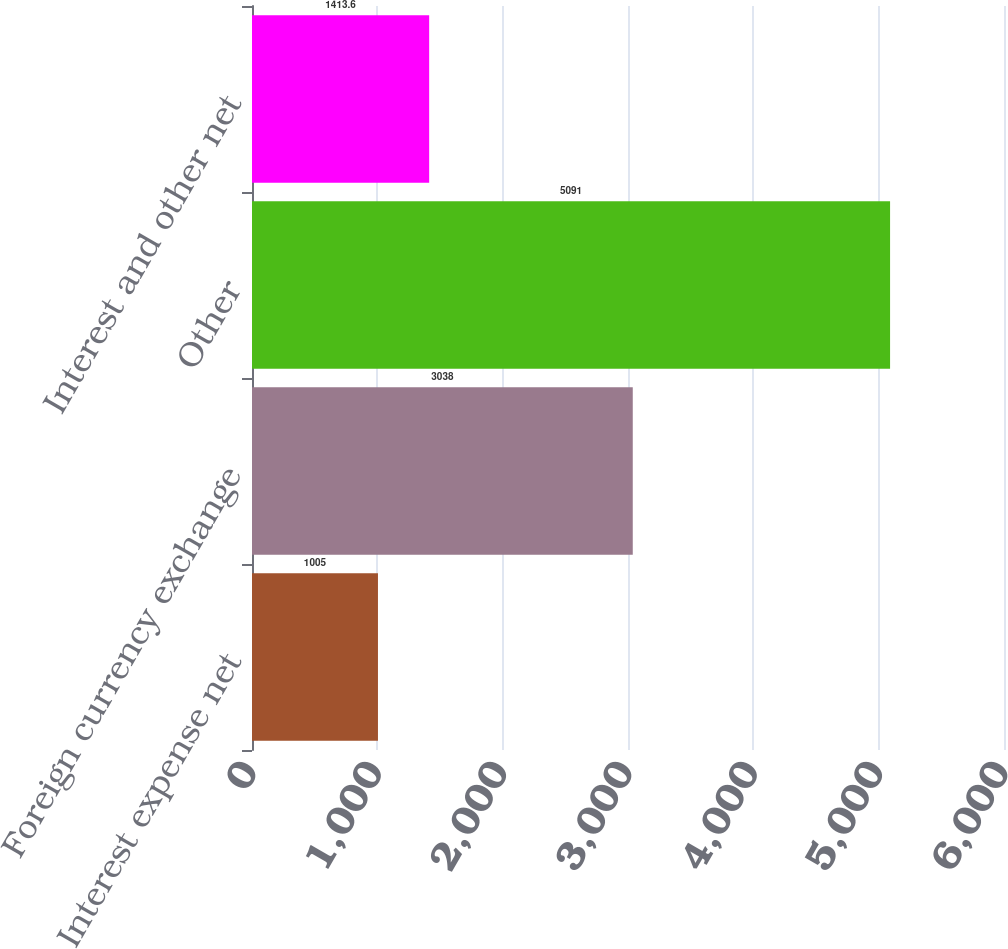Convert chart. <chart><loc_0><loc_0><loc_500><loc_500><bar_chart><fcel>Interest expense net<fcel>Foreign currency exchange<fcel>Other<fcel>Interest and other net<nl><fcel>1005<fcel>3038<fcel>5091<fcel>1413.6<nl></chart> 